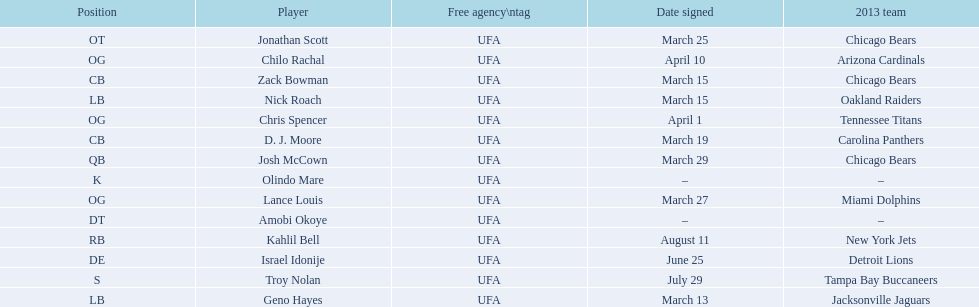Nick roach was signed the same day as what other player? Zack Bowman. 